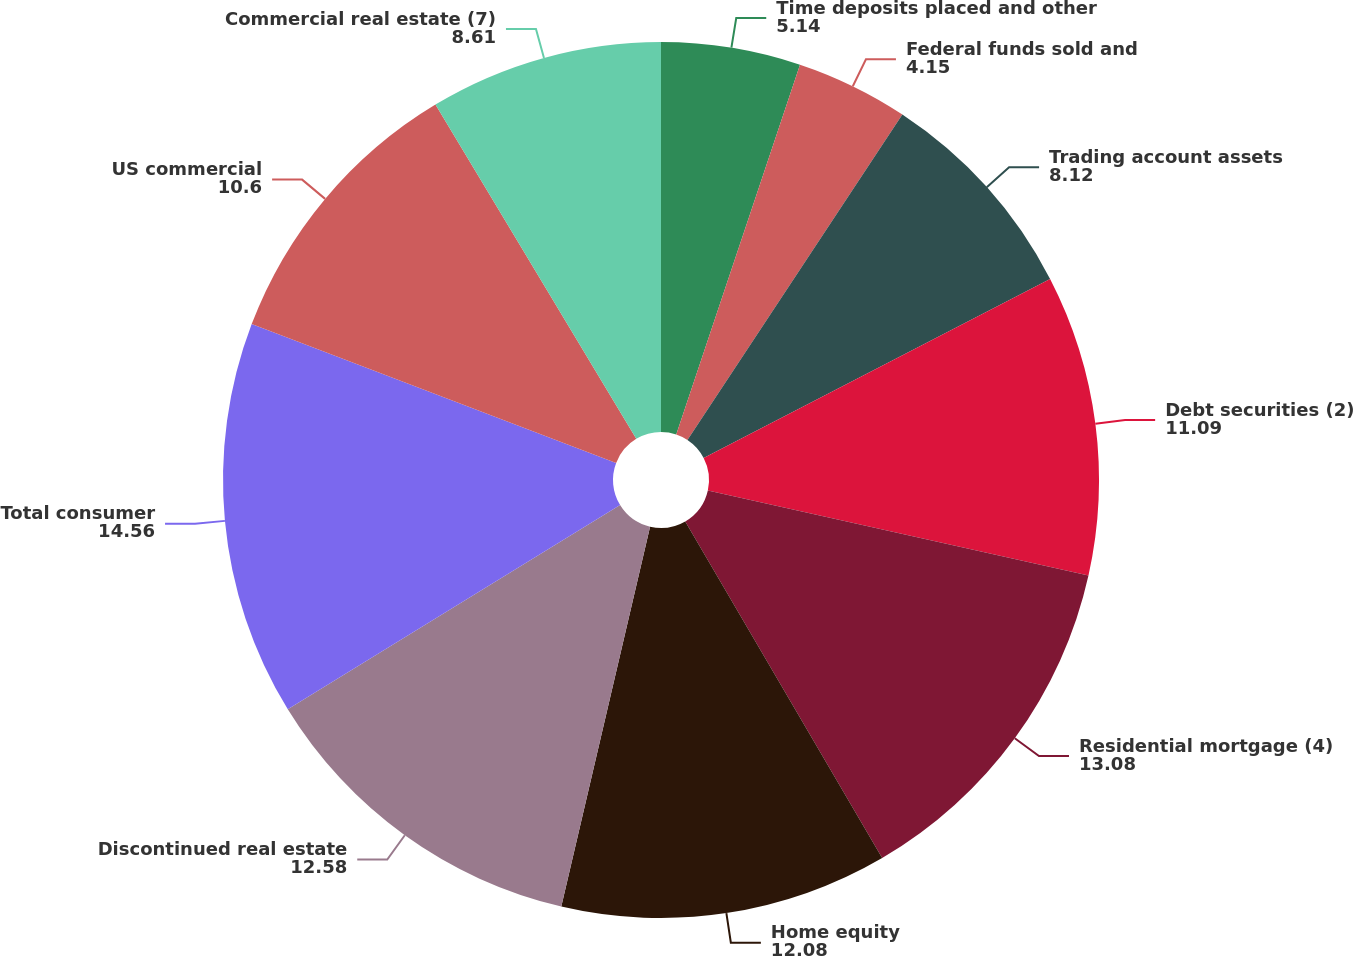<chart> <loc_0><loc_0><loc_500><loc_500><pie_chart><fcel>Time deposits placed and other<fcel>Federal funds sold and<fcel>Trading account assets<fcel>Debt securities (2)<fcel>Residential mortgage (4)<fcel>Home equity<fcel>Discontinued real estate<fcel>Total consumer<fcel>US commercial<fcel>Commercial real estate (7)<nl><fcel>5.14%<fcel>4.15%<fcel>8.12%<fcel>11.09%<fcel>13.08%<fcel>12.08%<fcel>12.58%<fcel>14.56%<fcel>10.6%<fcel>8.61%<nl></chart> 